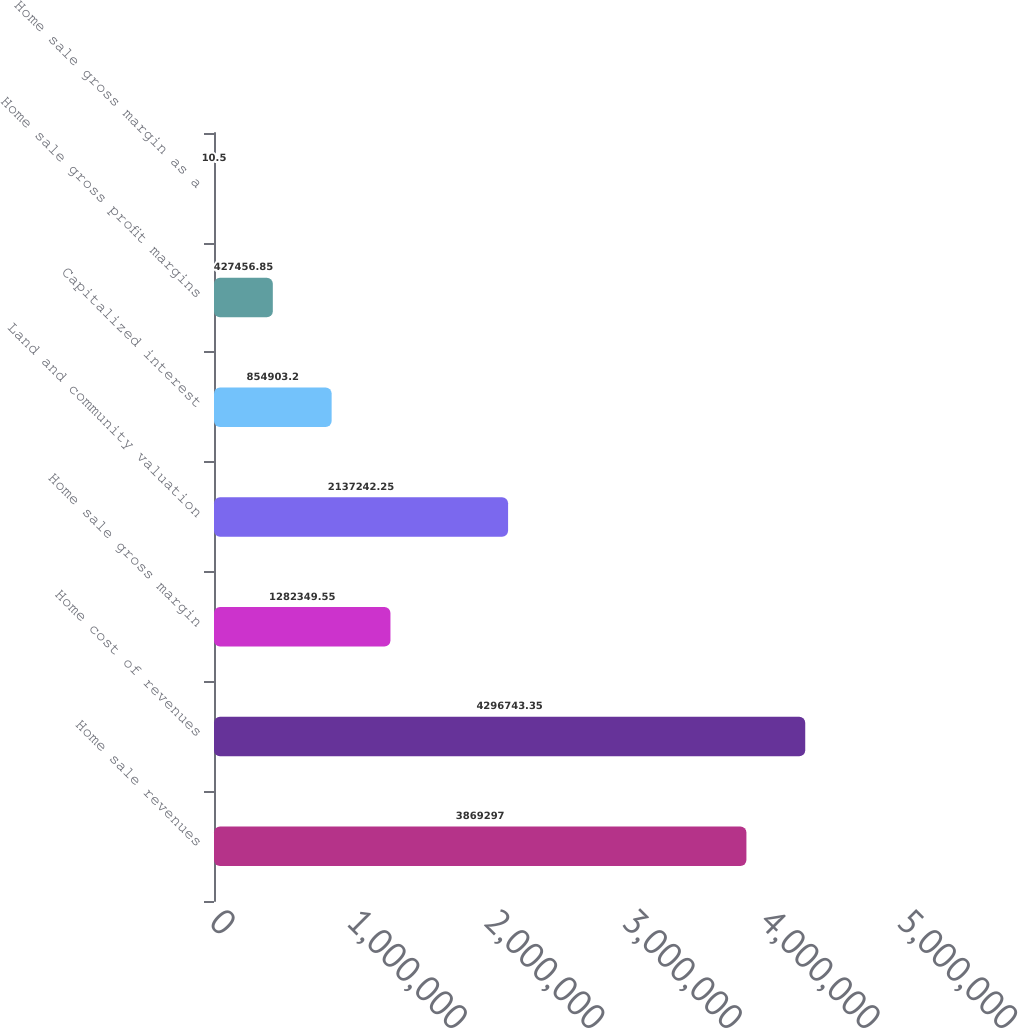Convert chart to OTSL. <chart><loc_0><loc_0><loc_500><loc_500><bar_chart><fcel>Home sale revenues<fcel>Home cost of revenues<fcel>Home sale gross margin<fcel>Land and community valuation<fcel>Capitalized interest<fcel>Home sale gross profit margins<fcel>Home sale gross margin as a<nl><fcel>3.8693e+06<fcel>4.29674e+06<fcel>1.28235e+06<fcel>2.13724e+06<fcel>854903<fcel>427457<fcel>10.5<nl></chart> 